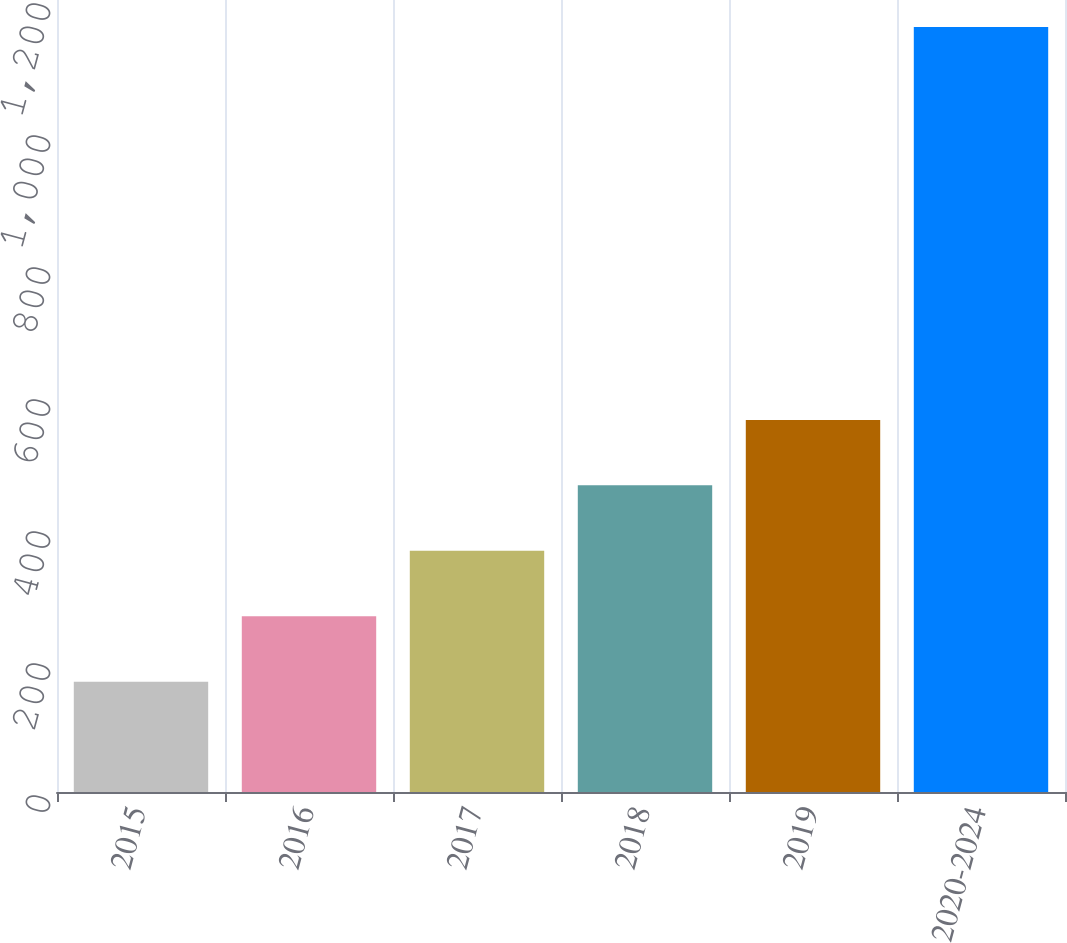Convert chart to OTSL. <chart><loc_0><loc_0><loc_500><loc_500><bar_chart><fcel>2015<fcel>2016<fcel>2017<fcel>2018<fcel>2019<fcel>2020-2024<nl><fcel>167<fcel>266.2<fcel>365.4<fcel>464.6<fcel>563.8<fcel>1159<nl></chart> 